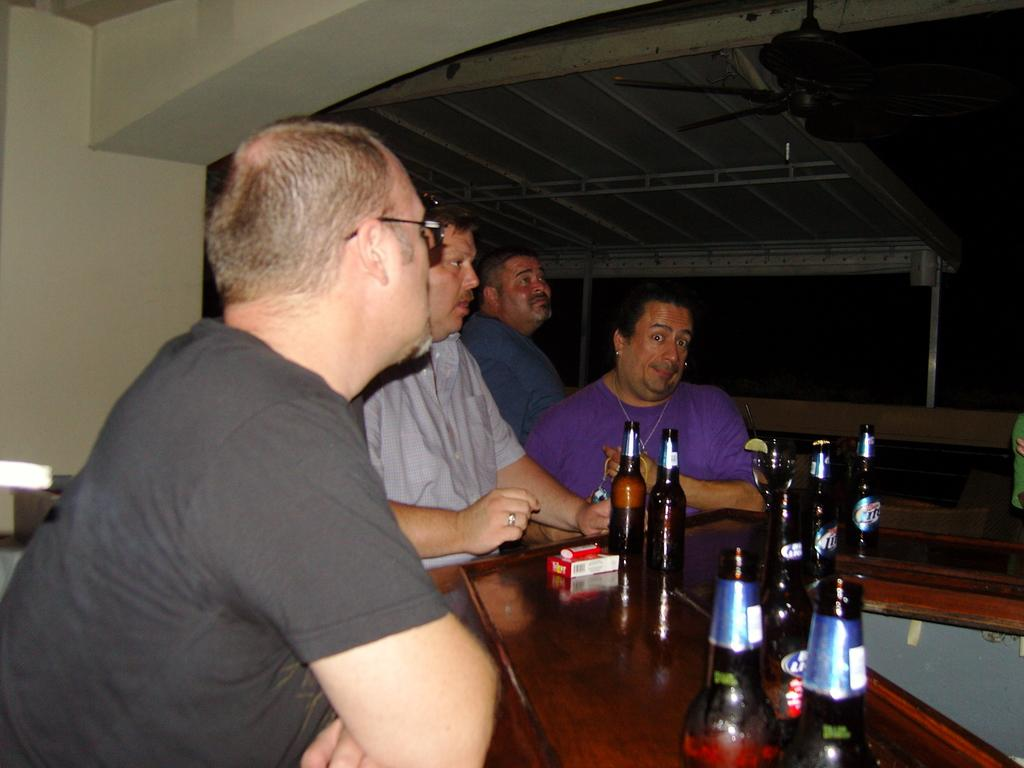How many people are present in the image? There are four people in the image. What objects can be seen on the table in the image? There are bottles on a table in the image. Can you describe any other objects visible in the image? There is a fan visible at the top of the image. Are there any goldfish swimming in the bottles on the table? There are no goldfish present in the image; the bottles contain unspecified contents. 